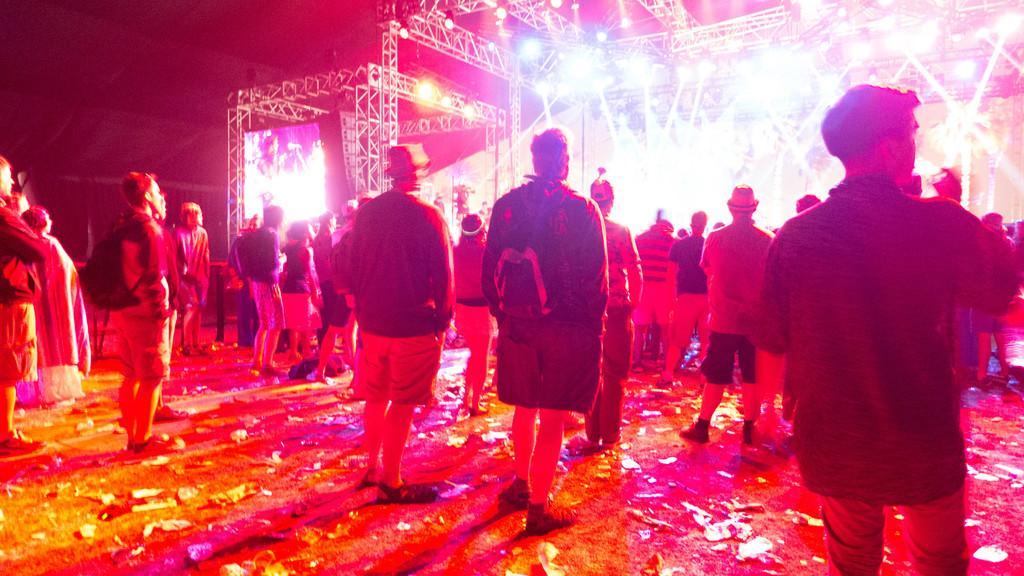Please provide a concise description of this image. In this image there are people standing on a ground, in the background there are metal frames, lights and screens. 